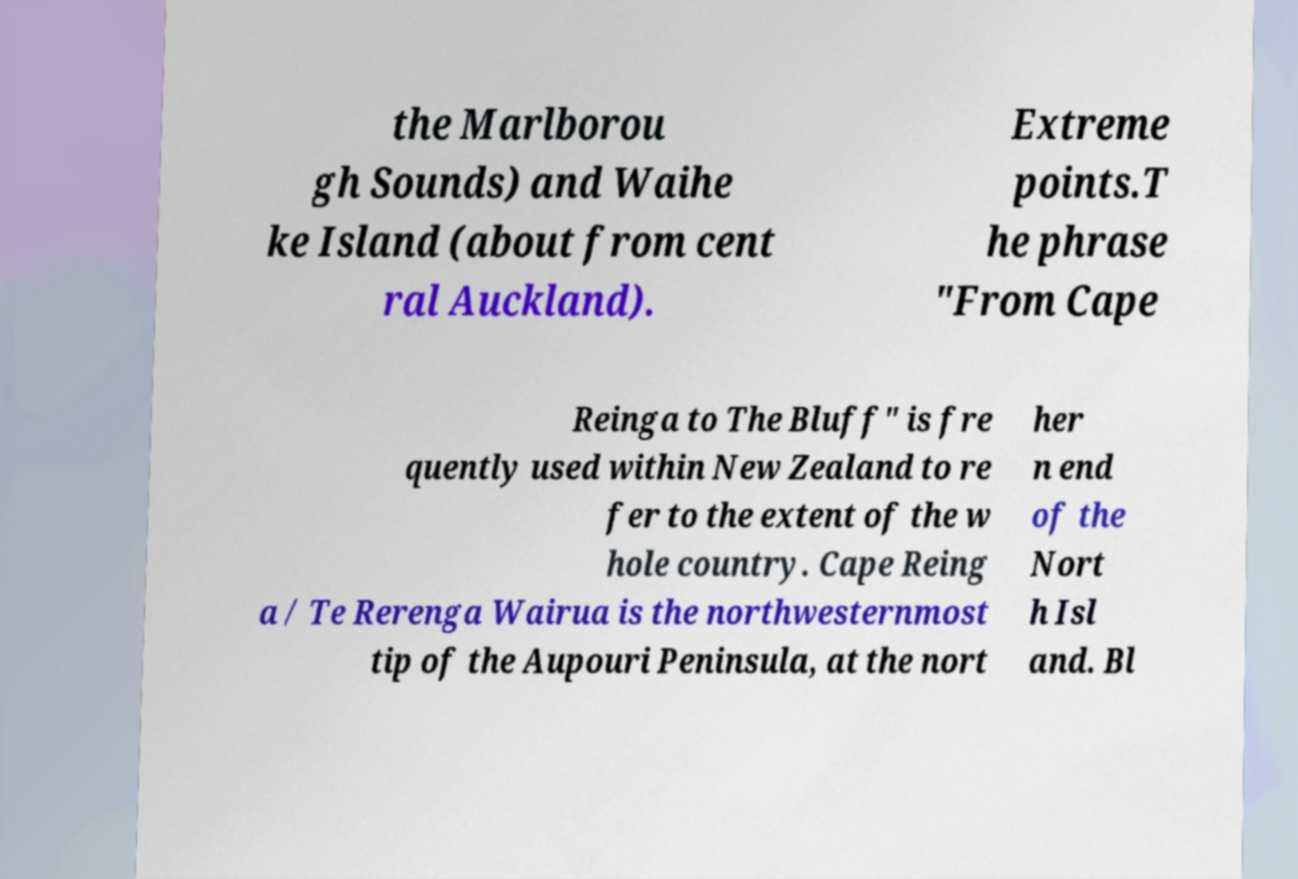I need the written content from this picture converted into text. Can you do that? the Marlborou gh Sounds) and Waihe ke Island (about from cent ral Auckland). Extreme points.T he phrase "From Cape Reinga to The Bluff" is fre quently used within New Zealand to re fer to the extent of the w hole country. Cape Reing a / Te Rerenga Wairua is the northwesternmost tip of the Aupouri Peninsula, at the nort her n end of the Nort h Isl and. Bl 